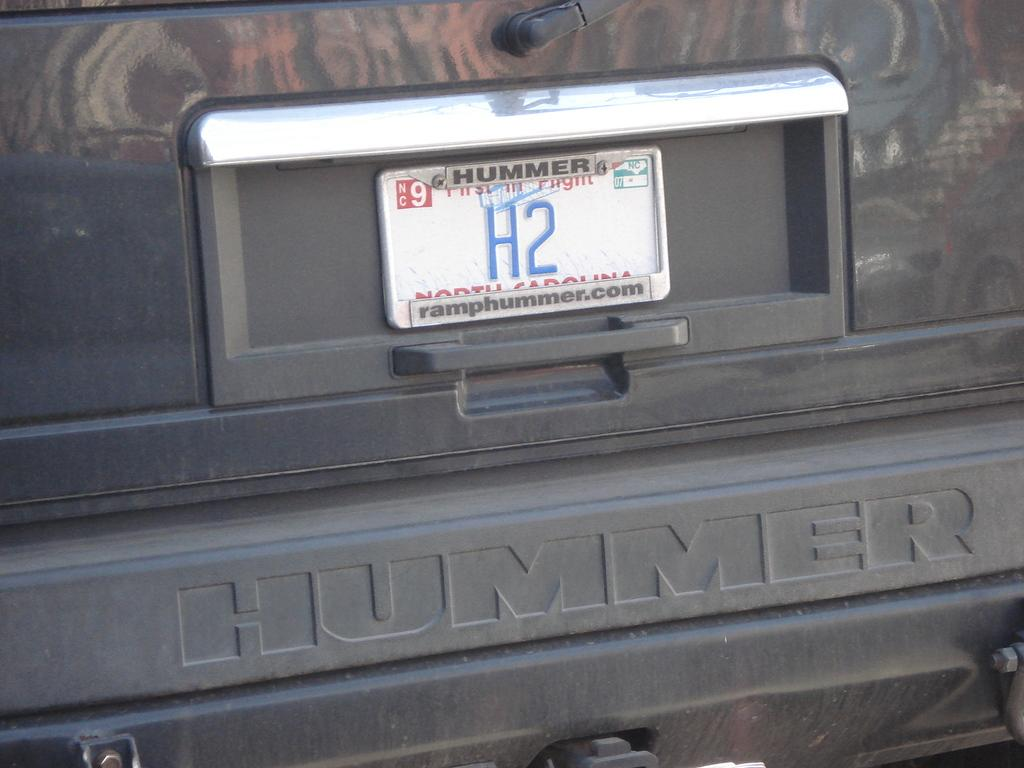What is present in the image that is related to vehicle identification? There is a number plate in the image. What part of a vehicle can be seen in the image? There is a door handle of a vehicle in the image. Can you describe any other objects present in the image? There are some unspecified objects in the image. What type of button can be seen being used to start the vehicle in the image? There is no button or indication of starting a vehicle present in the image. Where is the toothbrush located in the image? There is no toothbrush present in the image. 